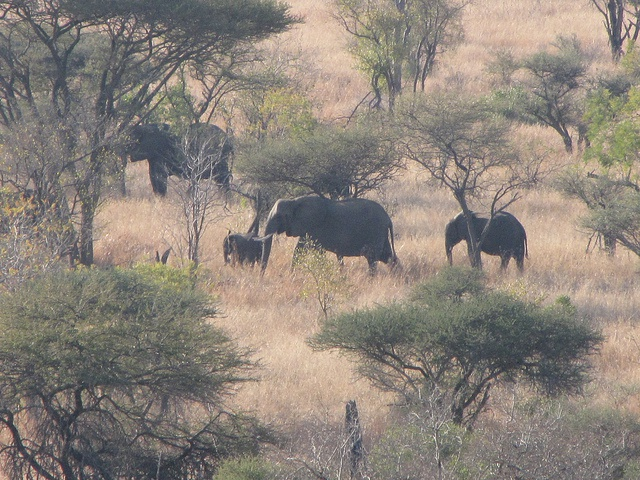Describe the objects in this image and their specific colors. I can see elephant in gray, darkgray, and black tones, elephant in gray, darkgray, and black tones, elephant in gray, darkgray, black, and tan tones, and elephant in gray and darkgray tones in this image. 